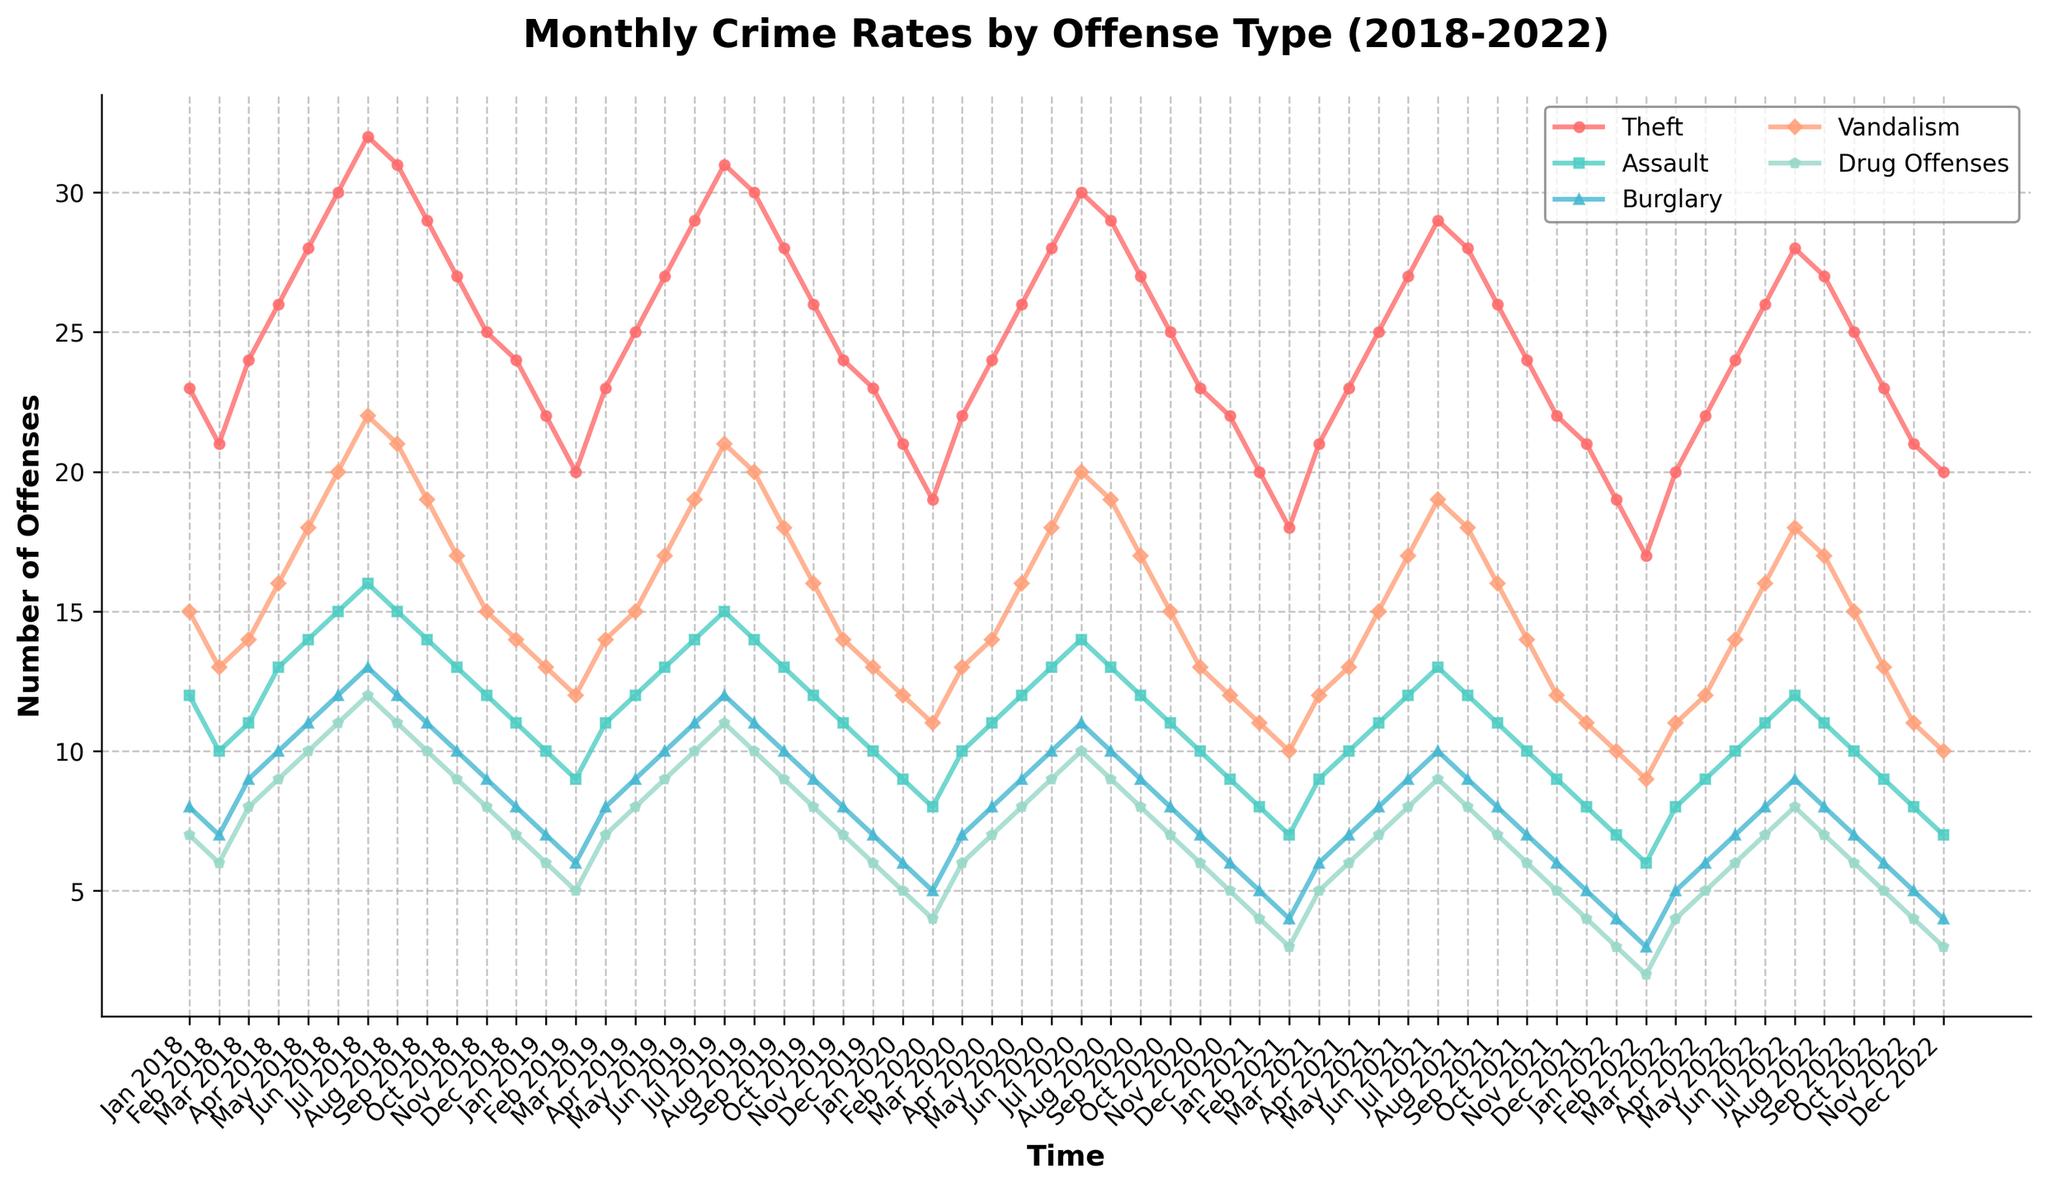What month and year saw the highest number of thefts? Look for the peak in the 'Theft' line on the chart. The highest point corresponds to July 2018.
Answer: July 2018 By how much did the total number of assaults decrease from January 2018 to December 2022? Look at the 'Assault' count in January 2018, which is 12, and in December 2022, which is 7. The decrease is 12 - 7 = 5.
Answer: 5 Which offense type had the most consistent (least variable) frequency throughout the 5 years? Observe the lines, looking for the one with the smallest vertical variance over time. 'Drug Offenses' appears to be the most consistent.
Answer: Drug Offenses Which two offense types had a crossing point in the number of offenses around mid-2020? Examine the lines for any points where they cross each other around mid-2020. 'Theft' and 'Burglary' cross paths around that time frame.
Answer: Theft and Burglary What was the total number of vandalism incidents recorded in 2019? Sum up the monthly vandalism data for 2019: 13+12+14+15+17+19+21+20+18+16+14+13 = 192.
Answer: 192 How does the trend in drug offenses from January 2021 to December 2021 compare to the trend in vandalism in the same period? Observe the slopes of the lines for drug offenses and vandalism from January 2021 to December 2021. Both show similar increasing trends.
Answer: Similar increasing trends What is the average monthly number of burglaries in the entire dataset? Add up the monthly burglary numbers and divide by the total number of months (60): (sum of all burglaries) / 60. Sum is 429, so 429 / 60 ≈ 7.15
Answer: 7.15 By how much did vandalism decrease from its peak in July 2018 to its lowest in February 2022? The peak of vandalism is in July 2018 at 22 and the lowest in February 2022 at 9. The decrease is 22 - 9 = 13.
Answer: 13 Which offense showed the steepest decline after 2018? Observe all the lines post-2018; 'Theft' shows the steepest declining trend. Its high in 2018 was around 32, and it decreased steadily over time.
Answer: Theft By what percentage did the monthly number of drug offenses change from January 2018 to July 2022? Calculate the drug offenses for January 2018 (7) and July 2022 (8), then calculate the percentage change: ((8 - 7) / 7) * 100 = 14.29%.
Answer: 14.29% 